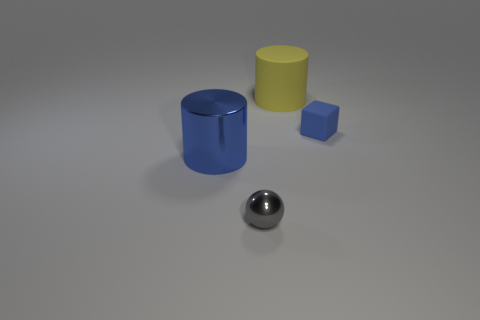Does the metal cylinder have the same color as the rubber block?
Ensure brevity in your answer.  Yes. What is the size of the other blue object that is the same shape as the large matte thing?
Keep it short and to the point. Large. What number of objects have the same material as the small blue block?
Your answer should be compact. 1. Are there fewer large metallic objects that are in front of the tiny block than big blue shiny things?
Provide a short and direct response. No. How many yellow matte cubes are there?
Your response must be concise. 0. What number of tiny rubber blocks are the same color as the small shiny thing?
Provide a short and direct response. 0. Does the large metallic object have the same shape as the large yellow rubber thing?
Make the answer very short. Yes. There is a cylinder that is behind the cylinder on the left side of the small gray metallic thing; how big is it?
Provide a succinct answer. Large. Are there any blocks of the same size as the yellow rubber cylinder?
Your response must be concise. No. There is a cylinder that is behind the large blue cylinder; is it the same size as the blue object to the left of the yellow thing?
Your answer should be very brief. Yes. 